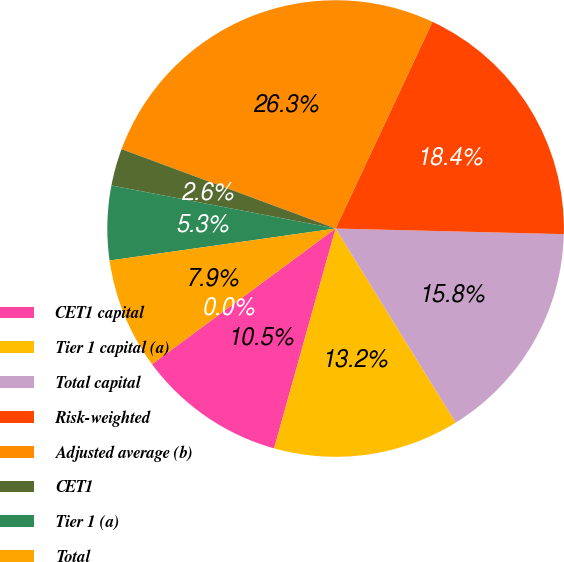<chart> <loc_0><loc_0><loc_500><loc_500><pie_chart><fcel>CET1 capital<fcel>Tier 1 capital (a)<fcel>Total capital<fcel>Risk-weighted<fcel>Adjusted average (b)<fcel>CET1<fcel>Tier 1 (a)<fcel>Total<fcel>Tier 1 leverage (d)<nl><fcel>10.53%<fcel>13.16%<fcel>15.79%<fcel>18.42%<fcel>26.32%<fcel>2.63%<fcel>5.26%<fcel>7.89%<fcel>0.0%<nl></chart> 